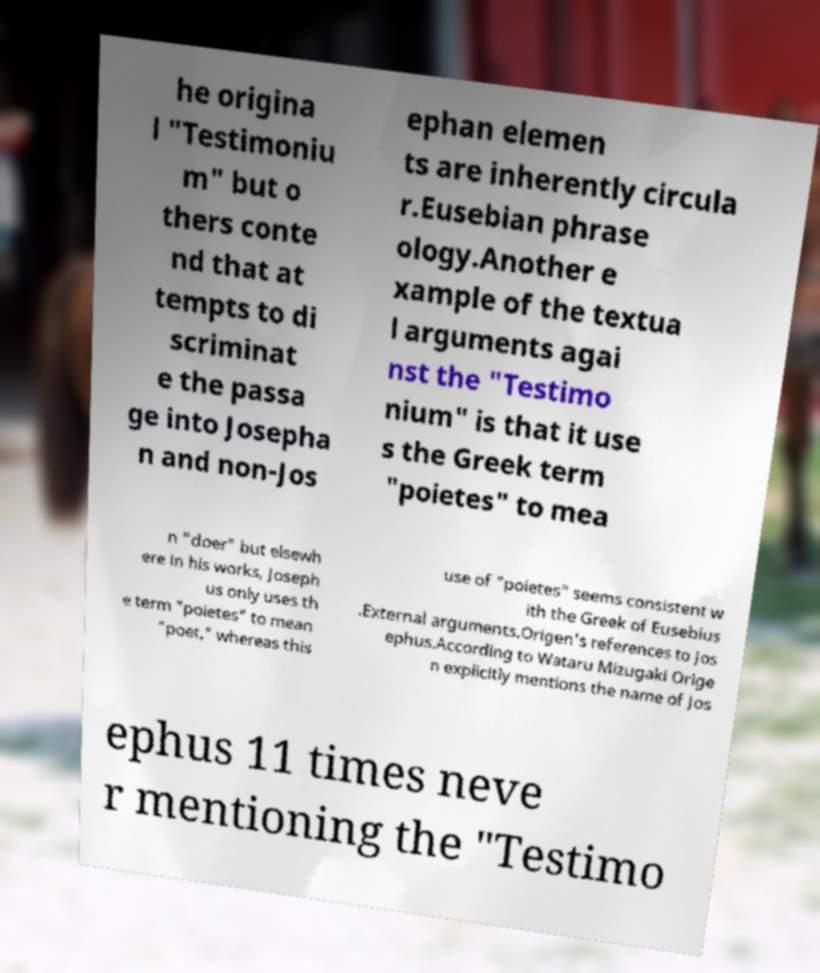Can you accurately transcribe the text from the provided image for me? he origina l "Testimoniu m" but o thers conte nd that at tempts to di scriminat e the passa ge into Josepha n and non-Jos ephan elemen ts are inherently circula r.Eusebian phrase ology.Another e xample of the textua l arguments agai nst the "Testimo nium" is that it use s the Greek term "poietes" to mea n "doer" but elsewh ere in his works, Joseph us only uses th e term "poietes" to mean "poet," whereas this use of "poietes" seems consistent w ith the Greek of Eusebius .External arguments.Origen's references to Jos ephus.According to Wataru Mizugaki Orige n explicitly mentions the name of Jos ephus 11 times neve r mentioning the "Testimo 